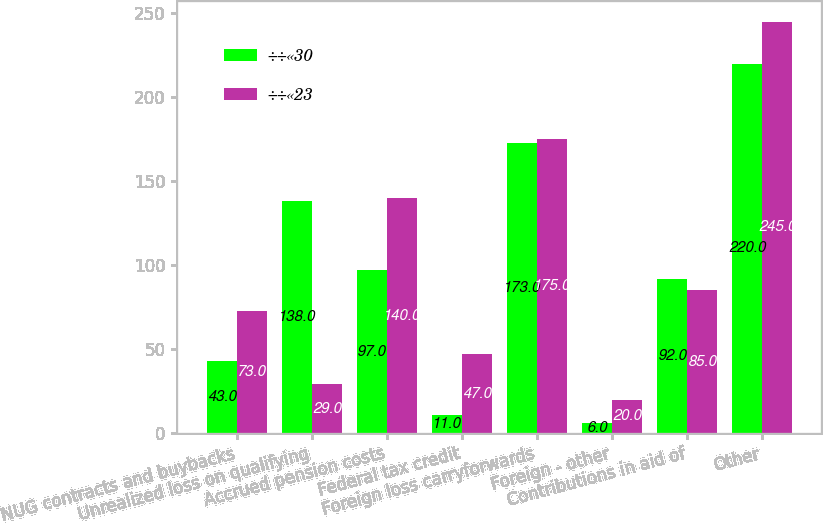<chart> <loc_0><loc_0><loc_500><loc_500><stacked_bar_chart><ecel><fcel>NUG contracts and buybacks<fcel>Unrealized loss on qualifying<fcel>Accrued pension costs<fcel>Federal tax credit<fcel>Foreign loss carryforwards<fcel>Foreign - other<fcel>Contributions in aid of<fcel>Other<nl><fcel>÷÷«30<fcel>43<fcel>138<fcel>97<fcel>11<fcel>173<fcel>6<fcel>92<fcel>220<nl><fcel>÷÷«23<fcel>73<fcel>29<fcel>140<fcel>47<fcel>175<fcel>20<fcel>85<fcel>245<nl></chart> 